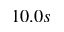Convert formula to latex. <formula><loc_0><loc_0><loc_500><loc_500>1 0 . 0 s</formula> 